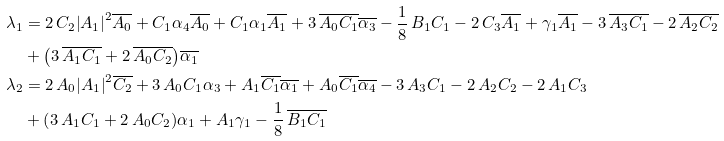Convert formula to latex. <formula><loc_0><loc_0><loc_500><loc_500>\lambda _ { 1 } & = 2 \, C _ { 2 } { \left | A _ { 1 } \right | } ^ { 2 } \overline { A _ { 0 } } + C _ { 1 } \alpha _ { 4 } \overline { A _ { 0 } } + C _ { 1 } \alpha _ { 1 } \overline { A _ { 1 } } + 3 \, \overline { A _ { 0 } } \overline { C _ { 1 } } \overline { \alpha _ { 3 } } - \frac { 1 } { 8 } \, B _ { 1 } C _ { 1 } - 2 \, C _ { 3 } \overline { A _ { 1 } } + \gamma _ { 1 } \overline { A _ { 1 } } - 3 \, \overline { A _ { 3 } } \overline { C _ { 1 } } - 2 \, \overline { A _ { 2 } } \overline { C _ { 2 } } \\ & + { \left ( 3 \, \overline { A _ { 1 } } \overline { C _ { 1 } } + 2 \, \overline { A _ { 0 } } \overline { C _ { 2 } } \right ) } \overline { \alpha _ { 1 } } \\ \lambda _ { 2 } & = 2 \, A _ { 0 } { \left | A _ { 1 } \right | } ^ { 2 } \overline { C _ { 2 } } + 3 \, A _ { 0 } C _ { 1 } \alpha _ { 3 } + A _ { 1 } \overline { C _ { 1 } } \overline { \alpha _ { 1 } } + A _ { 0 } \overline { C _ { 1 } } \overline { \alpha _ { 4 } } - 3 \, A _ { 3 } C _ { 1 } - 2 \, A _ { 2 } C _ { 2 } - 2 \, A _ { 1 } C _ { 3 } \\ & + { \left ( 3 \, A _ { 1 } C _ { 1 } + 2 \, A _ { 0 } C _ { 2 } \right ) } \alpha _ { 1 } + A _ { 1 } \gamma _ { 1 } - \frac { 1 } { 8 } \, \overline { B _ { 1 } } \overline { C _ { 1 } }</formula> 